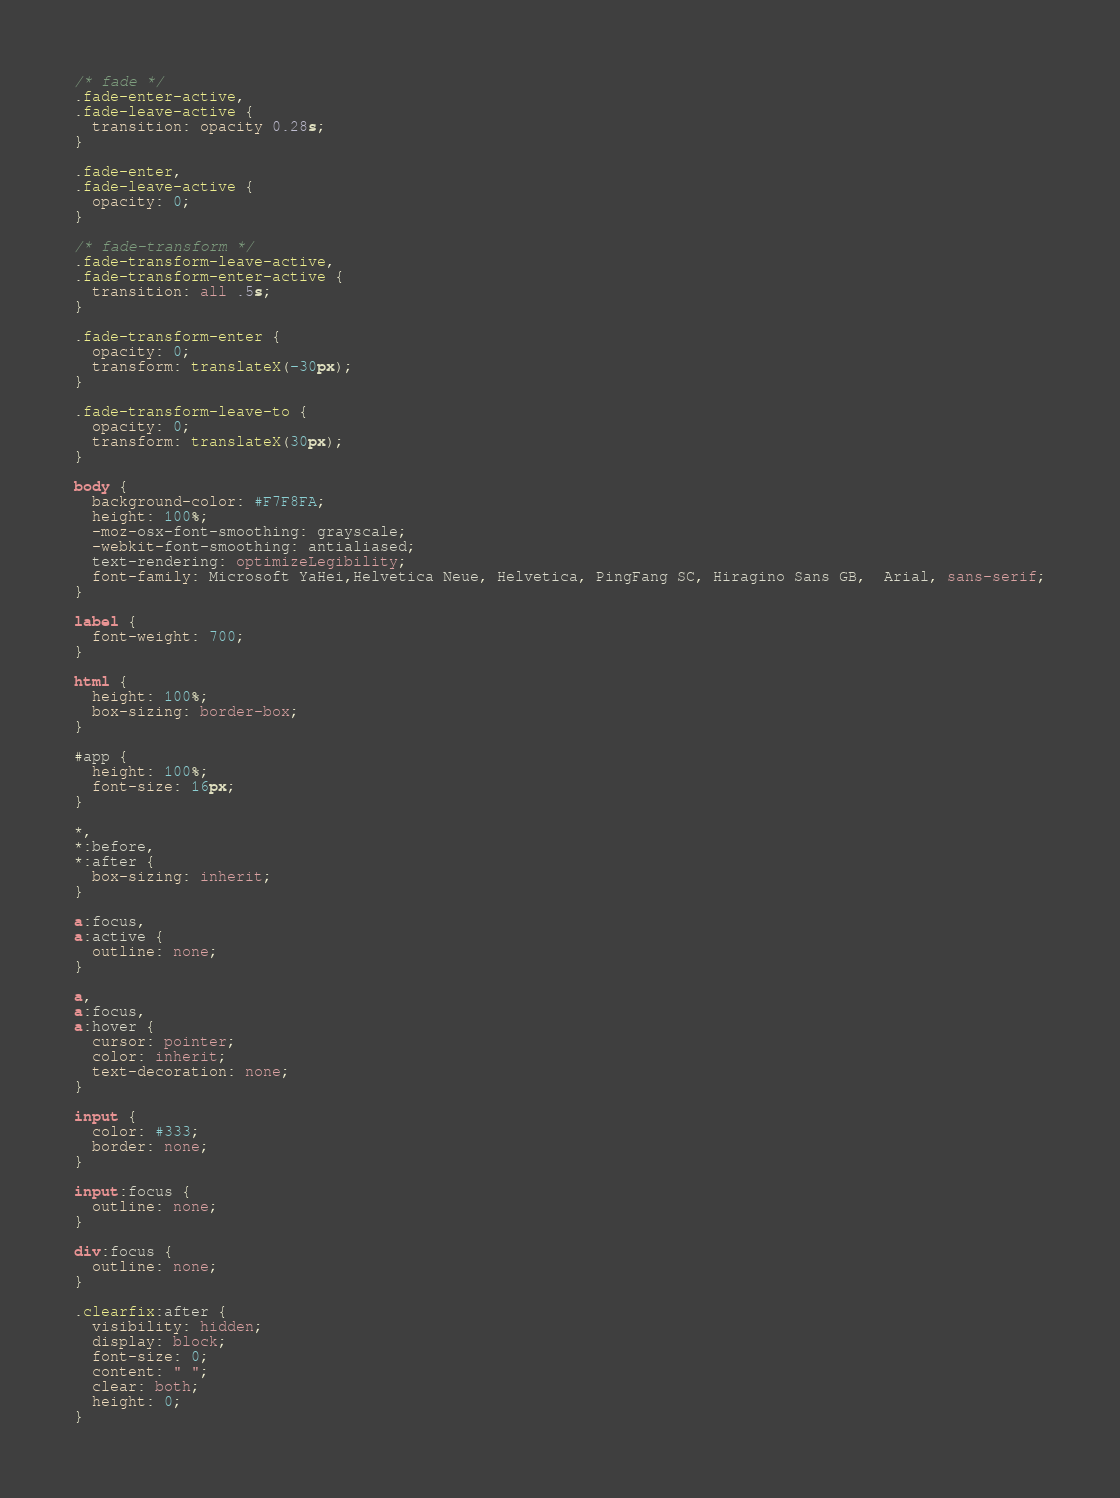Convert code to text. <code><loc_0><loc_0><loc_500><loc_500><_CSS_>/* fade */
.fade-enter-active,
.fade-leave-active {
  transition: opacity 0.28s;
}

.fade-enter,
.fade-leave-active {
  opacity: 0;
}

/* fade-transform */
.fade-transform-leave-active,
.fade-transform-enter-active {
  transition: all .5s;
}

.fade-transform-enter {
  opacity: 0;
  transform: translateX(-30px);
}

.fade-transform-leave-to {
  opacity: 0;
  transform: translateX(30px);
}

body {
  background-color: #F7F8FA;
  height: 100%;
  -moz-osx-font-smoothing: grayscale;
  -webkit-font-smoothing: antialiased;
  text-rendering: optimizeLegibility;
  font-family: Microsoft YaHei,Helvetica Neue, Helvetica, PingFang SC, Hiragino Sans GB,  Arial, sans-serif;
}

label {
  font-weight: 700;
}

html {
  height: 100%;
  box-sizing: border-box;
}

#app {
  height: 100%;
  font-size: 16px;
}

*,
*:before,
*:after {
  box-sizing: inherit;
}

a:focus,
a:active {
  outline: none;
}

a,
a:focus,
a:hover {
  cursor: pointer;
  color: inherit;
  text-decoration: none;
}

input {
  color: #333;
  border: none;
}

input:focus {
  outline: none;
}

div:focus {
  outline: none;
}

.clearfix:after {
  visibility: hidden;
  display: block;
  font-size: 0;
  content: " ";
  clear: both;
  height: 0;
}
</code> 